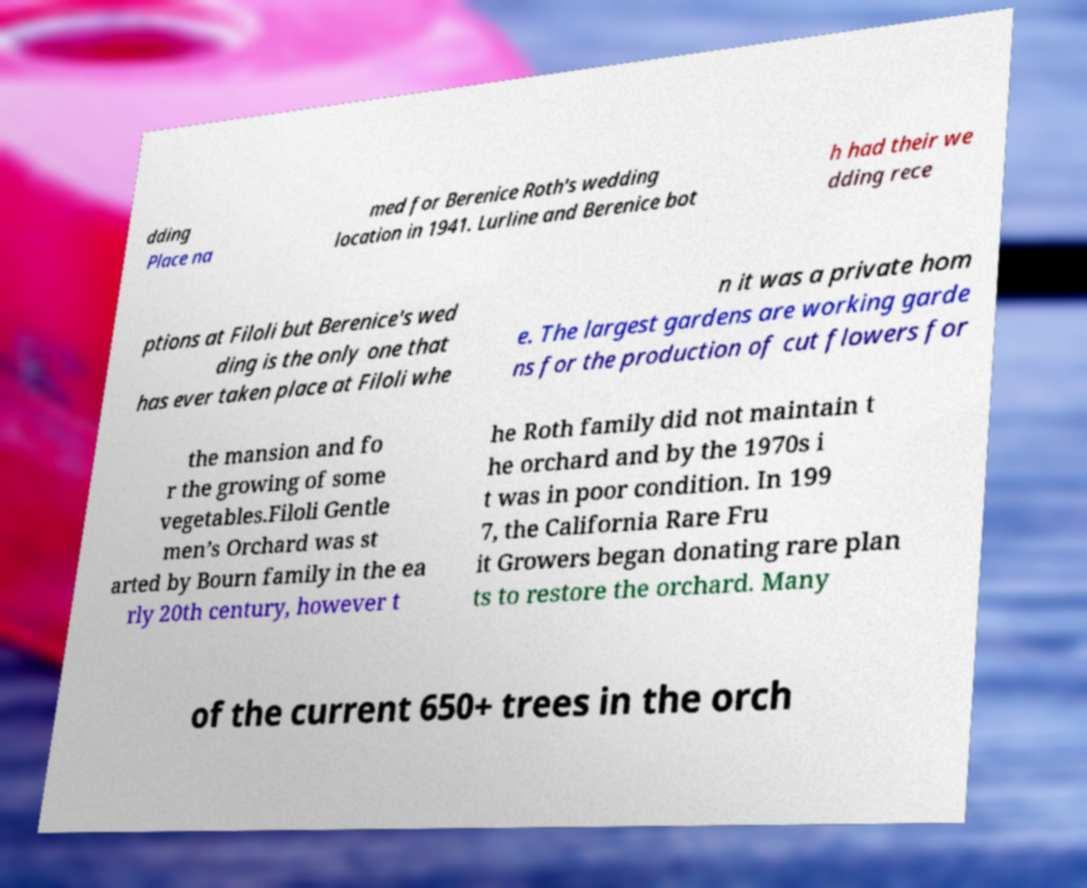Please read and relay the text visible in this image. What does it say? dding Place na med for Berenice Roth's wedding location in 1941. Lurline and Berenice bot h had their we dding rece ptions at Filoli but Berenice's wed ding is the only one that has ever taken place at Filoli whe n it was a private hom e. The largest gardens are working garde ns for the production of cut flowers for the mansion and fo r the growing of some vegetables.Filoli Gentle men’s Orchard was st arted by Bourn family in the ea rly 20th century, however t he Roth family did not maintain t he orchard and by the 1970s i t was in poor condition. In 199 7, the California Rare Fru it Growers began donating rare plan ts to restore the orchard. Many of the current 650+ trees in the orch 